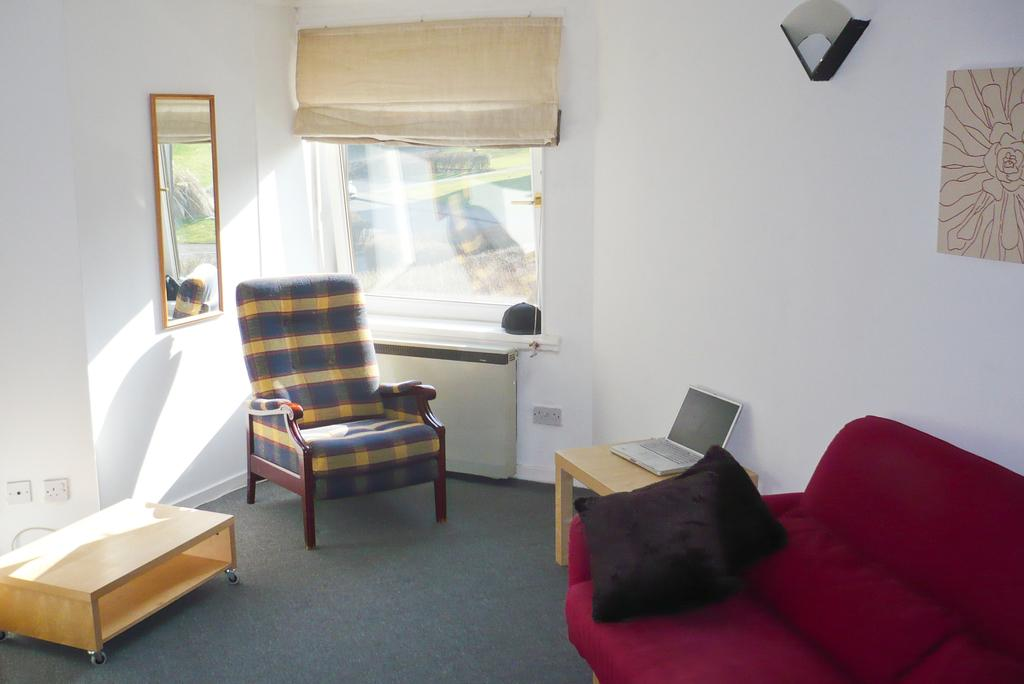What type of furniture is present in the image? There is a chair and a sofa in the image. What electronic device can be seen on a table in the image? There is a laptop on a table in the image. What type of accessory is present in the image? There is a cushion in the image. What decorative items are present on the walls in the image? There is a mirror and a painting on the walls in the image. What type of substance is being delivered to the house in the image? There is no indication of any substance delivery in the image; it only features furniture, a laptop, a cushion, a mirror, and a painting. 